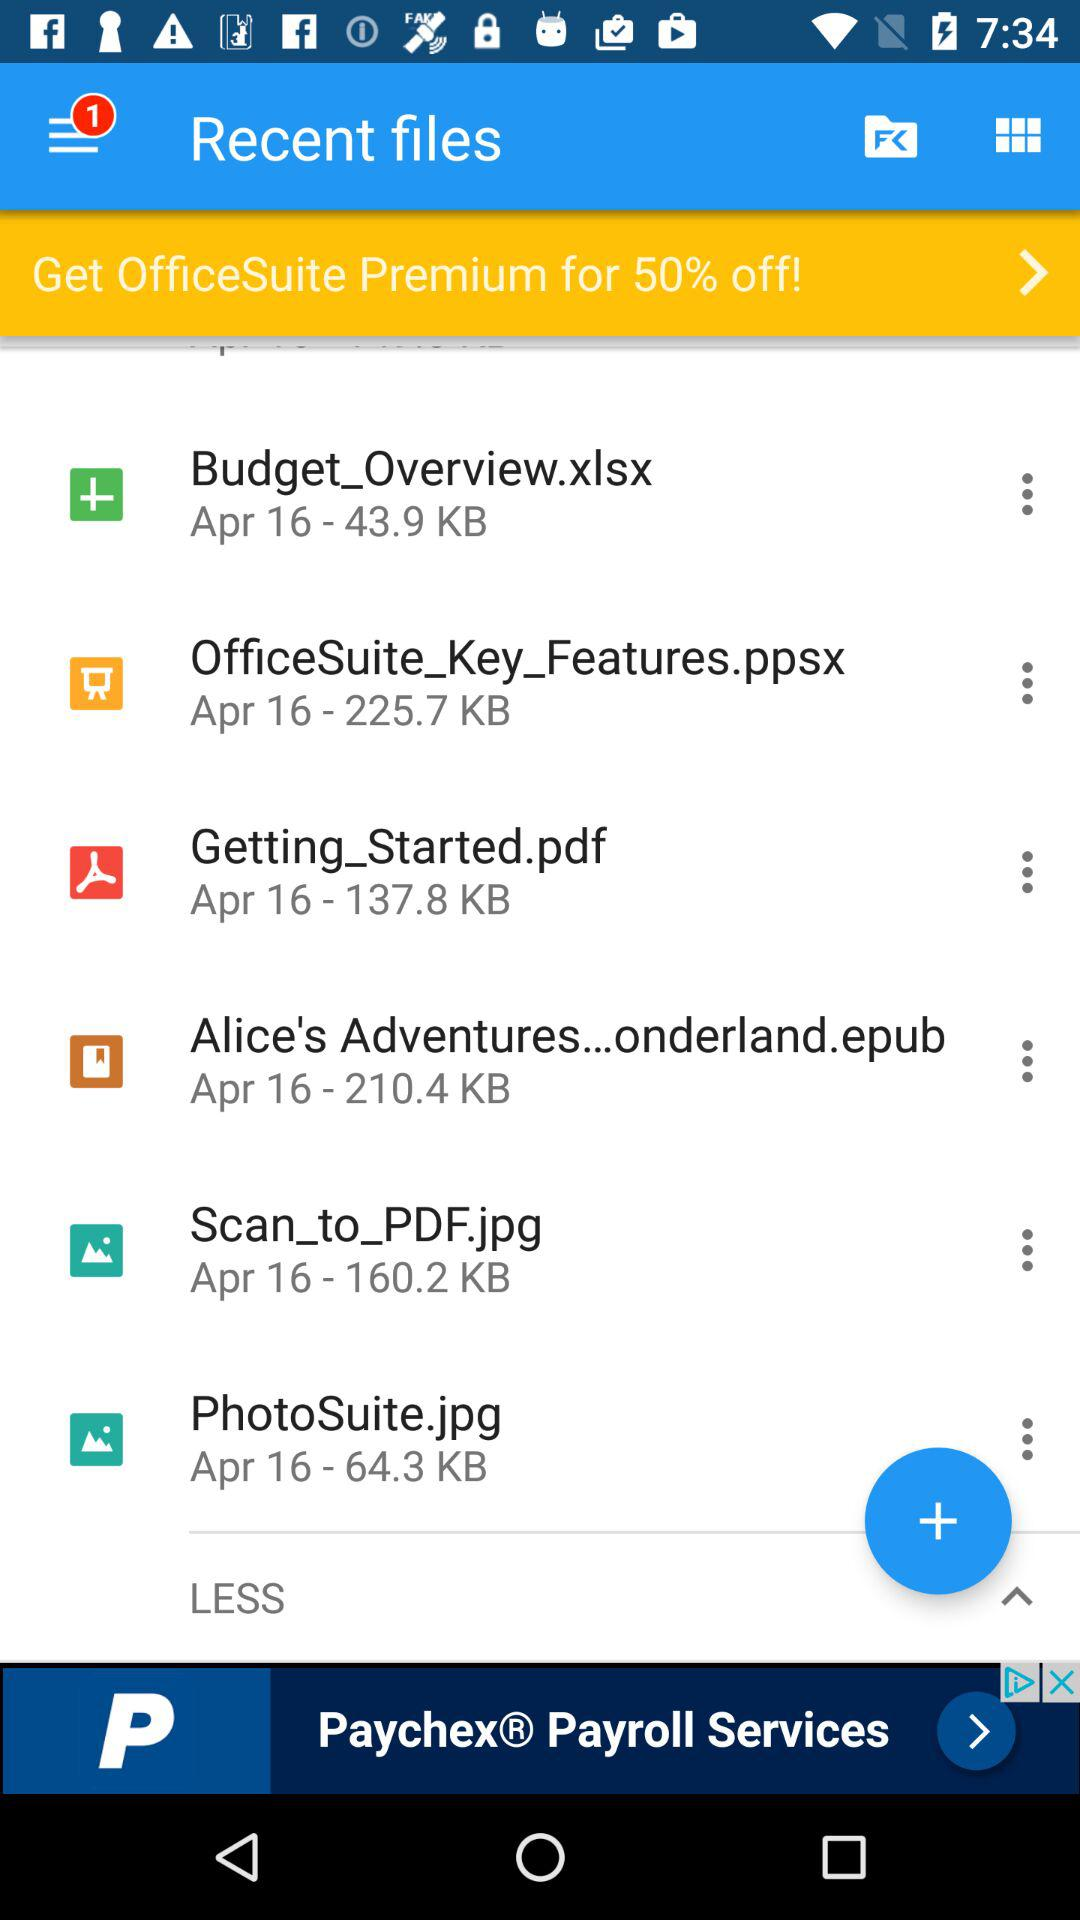How much space does the "PhotoSuite.jpg" file contain? The "PhotoSuite.jpg" file contains 64.3 KB of space. 